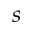<formula> <loc_0><loc_0><loc_500><loc_500>s</formula> 